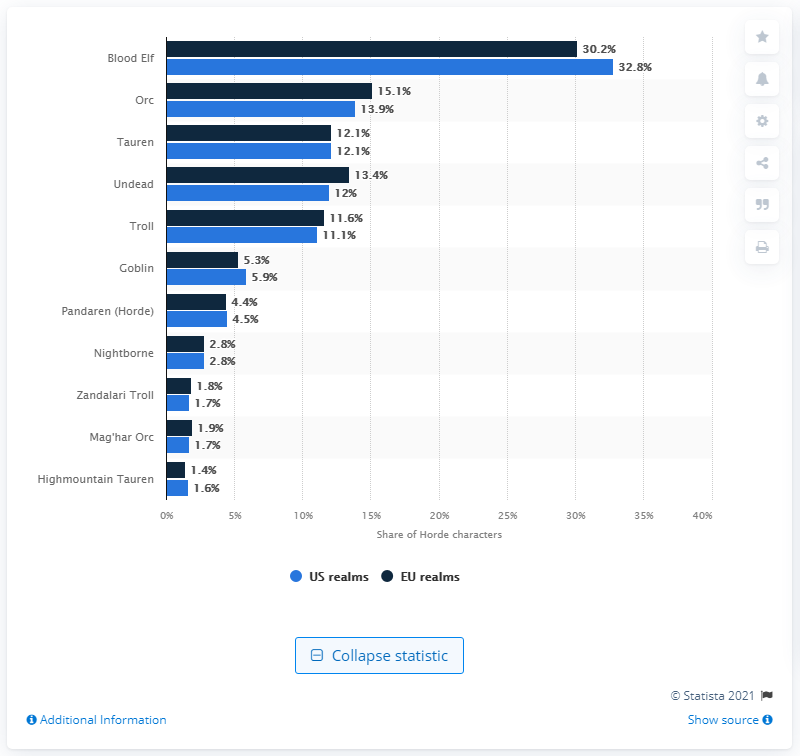Mention a couple of crucial points in this snapshot. In the U.S. as of December 2019, 32.9% of all Horde characters were Blood Elf. 